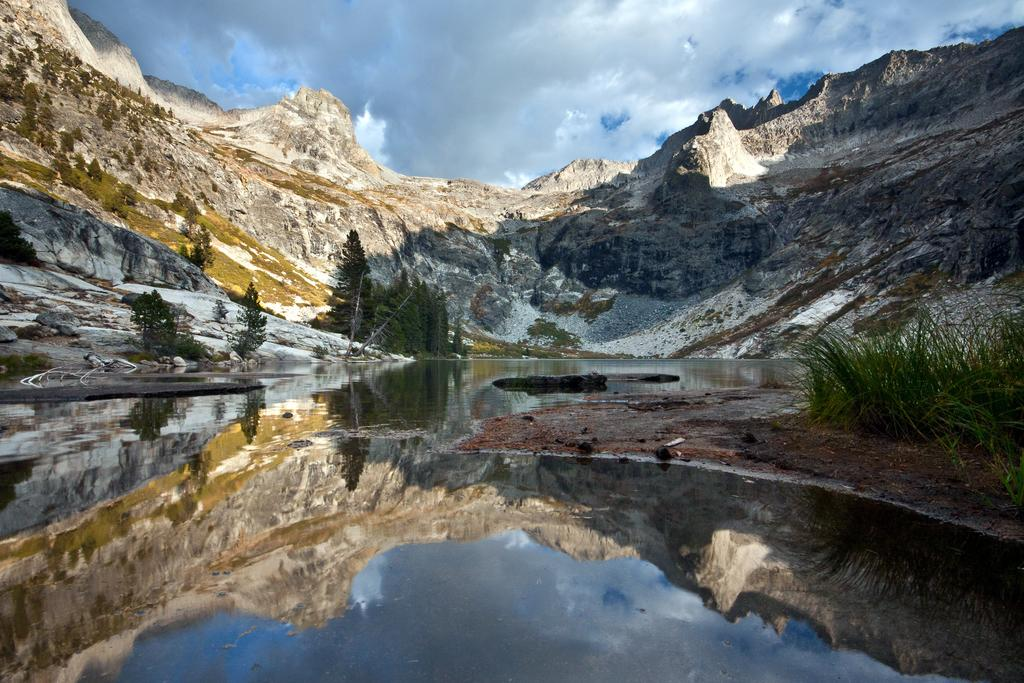What type of vegetation can be seen in the image? There are trees in the image. What body of water is present in the image? There is a lake in the image. What type of geological formation can be seen in the image? There are rocks and hills in the image. What type of ground cover is on the right side of the image? There is grass on the right side of the image. What is the condition of the sky in the image? The sky is cloudy behind the hills. Can you tell me how many turkeys are visible in the image? There are no turkeys present in the image. What type of monkey can be seen climbing the trees in the image? There are no monkeys present in the image, and therefore no such activity can be observed. 